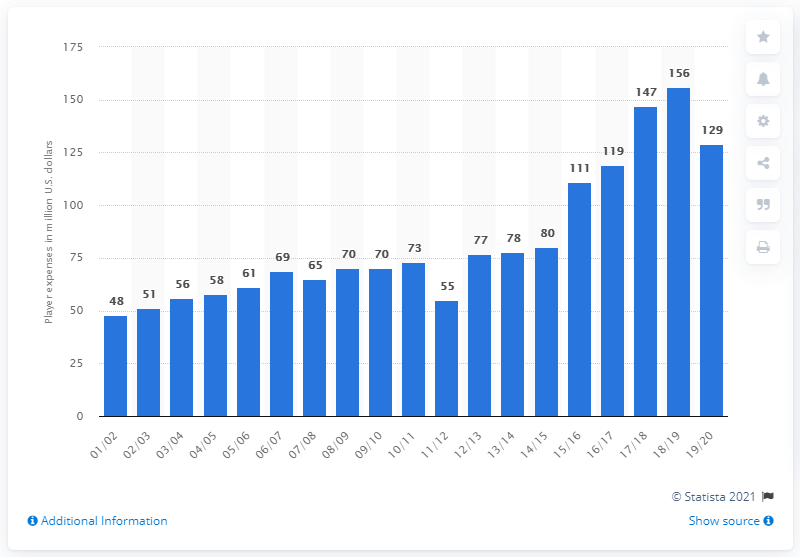List a handful of essential elements in this visual. The player salaries of the Golden State Warriors in the 2019/20 season were $129 million. 